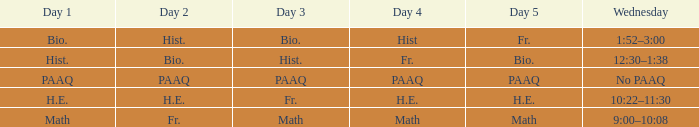Could you help me parse every detail presented in this table? {'header': ['Day 1', 'Day 2', 'Day 3', 'Day 4', 'Day 5', 'Wednesday'], 'rows': [['Bio.', 'Hist.', 'Bio.', 'Hist', 'Fr.', '1:52–3:00'], ['Hist.', 'Bio.', 'Hist.', 'Fr.', 'Bio.', '12:30–1:38'], ['PAAQ', 'PAAQ', 'PAAQ', 'PAAQ', 'PAAQ', 'No PAAQ'], ['H.E.', 'H.E.', 'Fr.', 'H.E.', 'H.E.', '10:22–11:30'], ['Math', 'Fr.', 'Math', 'Math', 'Math', '9:00–10:08']]} What is the day 1 when the day 3 is math? Math. 